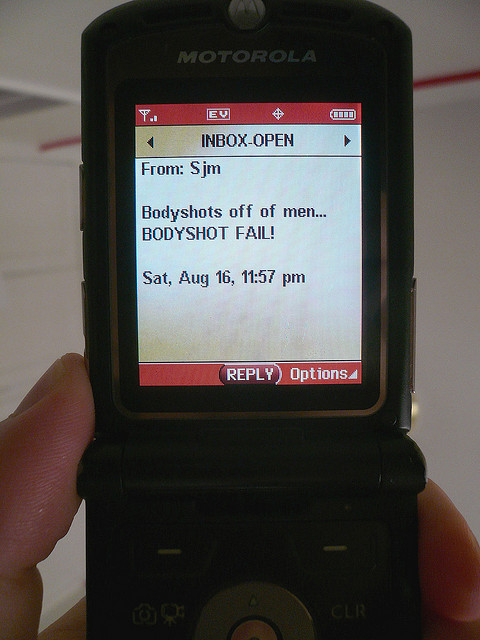<image>What model of phone is this? I am not sure about the model of the phone. It could be Motorola or Nokia. What model of phone is this? I don't know what model of phone it is. It could be a flip phone, an old Nokia, or a Motorola. 